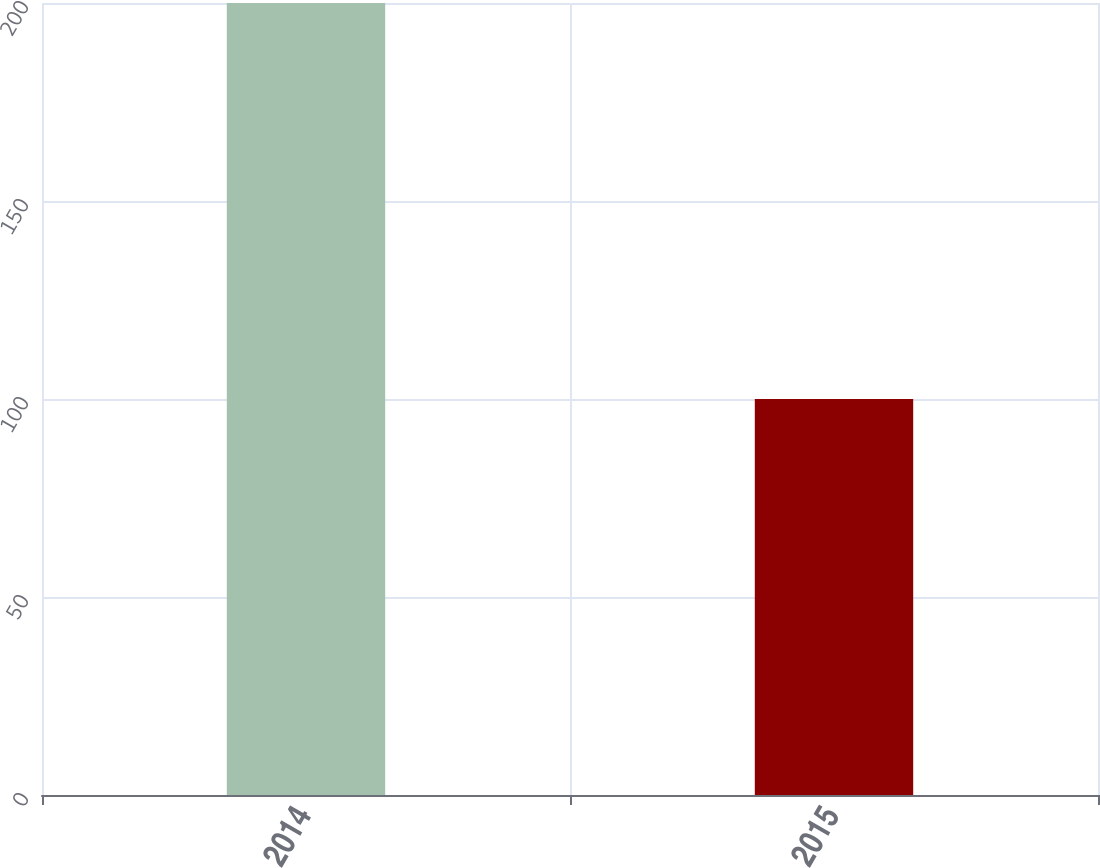<chart> <loc_0><loc_0><loc_500><loc_500><bar_chart><fcel>2014<fcel>2015<nl><fcel>200<fcel>100<nl></chart> 